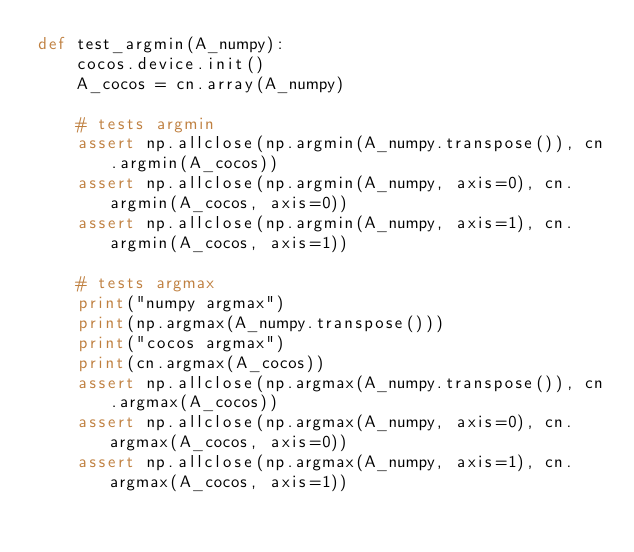Convert code to text. <code><loc_0><loc_0><loc_500><loc_500><_Python_>def test_argmin(A_numpy):
    cocos.device.init()
    A_cocos = cn.array(A_numpy)

    # tests argmin
    assert np.allclose(np.argmin(A_numpy.transpose()), cn.argmin(A_cocos))
    assert np.allclose(np.argmin(A_numpy, axis=0), cn.argmin(A_cocos, axis=0))
    assert np.allclose(np.argmin(A_numpy, axis=1), cn.argmin(A_cocos, axis=1))

    # tests argmax
    print("numpy argmax")
    print(np.argmax(A_numpy.transpose()))
    print("cocos argmax")
    print(cn.argmax(A_cocos))
    assert np.allclose(np.argmax(A_numpy.transpose()), cn.argmax(A_cocos))
    assert np.allclose(np.argmax(A_numpy, axis=0), cn.argmax(A_cocos, axis=0))
    assert np.allclose(np.argmax(A_numpy, axis=1), cn.argmax(A_cocos, axis=1))
</code> 